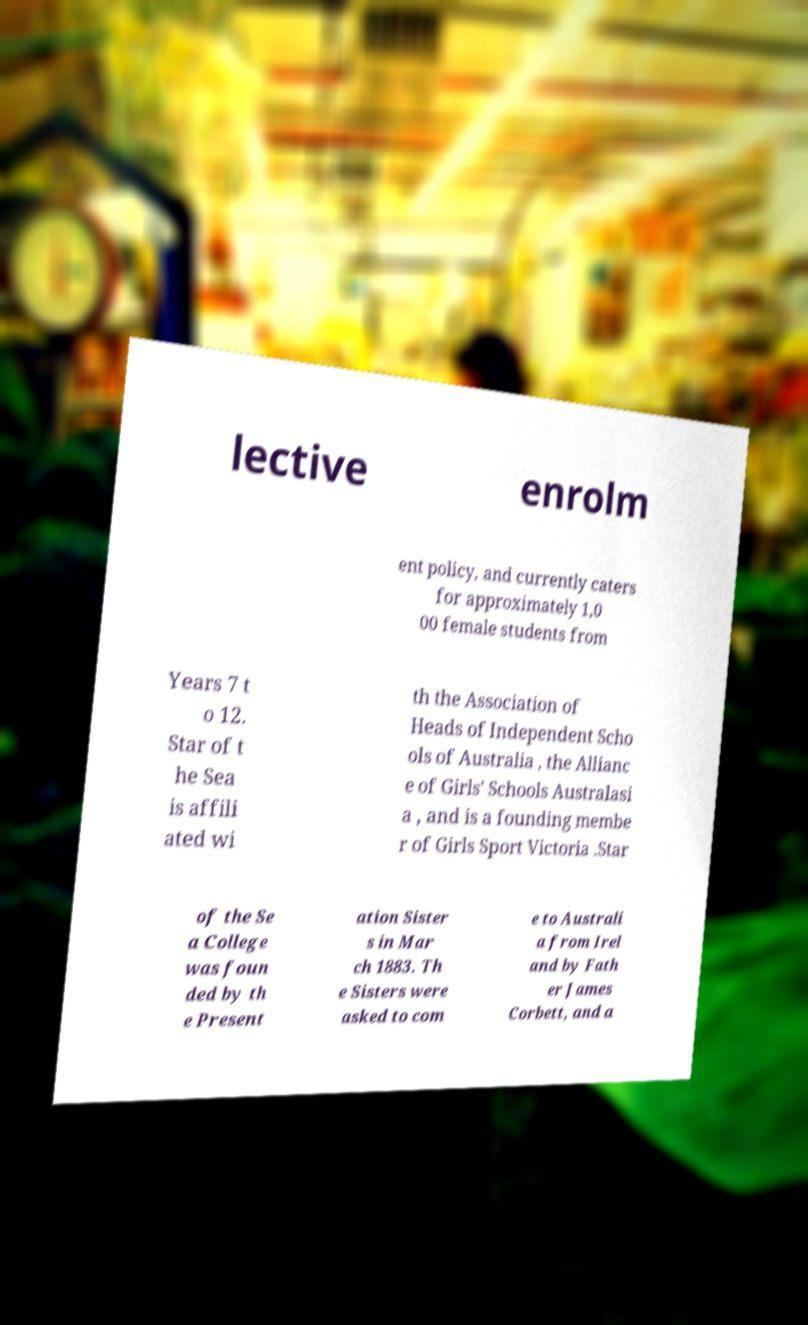Could you extract and type out the text from this image? lective enrolm ent policy, and currently caters for approximately 1,0 00 female students from Years 7 t o 12. Star of t he Sea is affili ated wi th the Association of Heads of Independent Scho ols of Australia , the Allianc e of Girls' Schools Australasi a , and is a founding membe r of Girls Sport Victoria .Star of the Se a College was foun ded by th e Present ation Sister s in Mar ch 1883. Th e Sisters were asked to com e to Australi a from Irel and by Fath er James Corbett, and a 